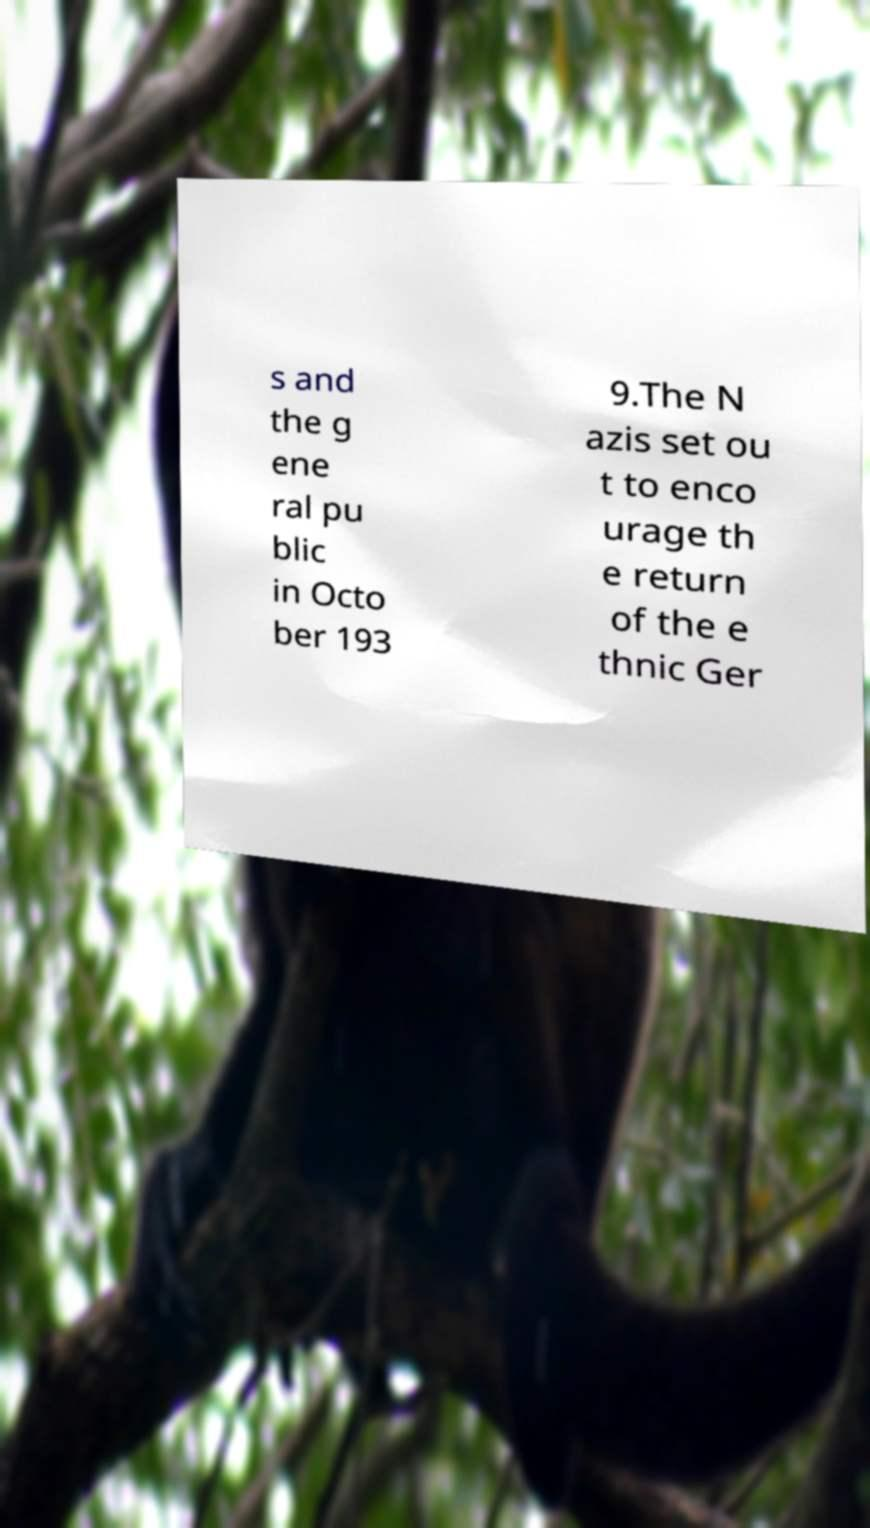There's text embedded in this image that I need extracted. Can you transcribe it verbatim? s and the g ene ral pu blic in Octo ber 193 9.The N azis set ou t to enco urage th e return of the e thnic Ger 